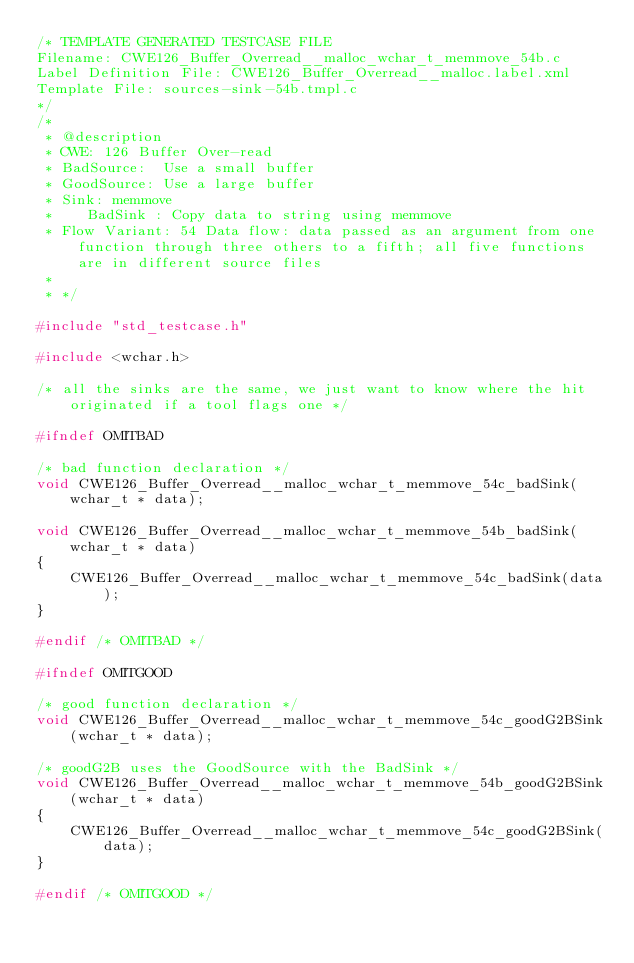Convert code to text. <code><loc_0><loc_0><loc_500><loc_500><_C_>/* TEMPLATE GENERATED TESTCASE FILE
Filename: CWE126_Buffer_Overread__malloc_wchar_t_memmove_54b.c
Label Definition File: CWE126_Buffer_Overread__malloc.label.xml
Template File: sources-sink-54b.tmpl.c
*/
/*
 * @description
 * CWE: 126 Buffer Over-read
 * BadSource:  Use a small buffer
 * GoodSource: Use a large buffer
 * Sink: memmove
 *    BadSink : Copy data to string using memmove
 * Flow Variant: 54 Data flow: data passed as an argument from one function through three others to a fifth; all five functions are in different source files
 *
 * */

#include "std_testcase.h"

#include <wchar.h>

/* all the sinks are the same, we just want to know where the hit originated if a tool flags one */

#ifndef OMITBAD

/* bad function declaration */
void CWE126_Buffer_Overread__malloc_wchar_t_memmove_54c_badSink(wchar_t * data);

void CWE126_Buffer_Overread__malloc_wchar_t_memmove_54b_badSink(wchar_t * data)
{
    CWE126_Buffer_Overread__malloc_wchar_t_memmove_54c_badSink(data);
}

#endif /* OMITBAD */

#ifndef OMITGOOD

/* good function declaration */
void CWE126_Buffer_Overread__malloc_wchar_t_memmove_54c_goodG2BSink(wchar_t * data);

/* goodG2B uses the GoodSource with the BadSink */
void CWE126_Buffer_Overread__malloc_wchar_t_memmove_54b_goodG2BSink(wchar_t * data)
{
    CWE126_Buffer_Overread__malloc_wchar_t_memmove_54c_goodG2BSink(data);
}

#endif /* OMITGOOD */
</code> 